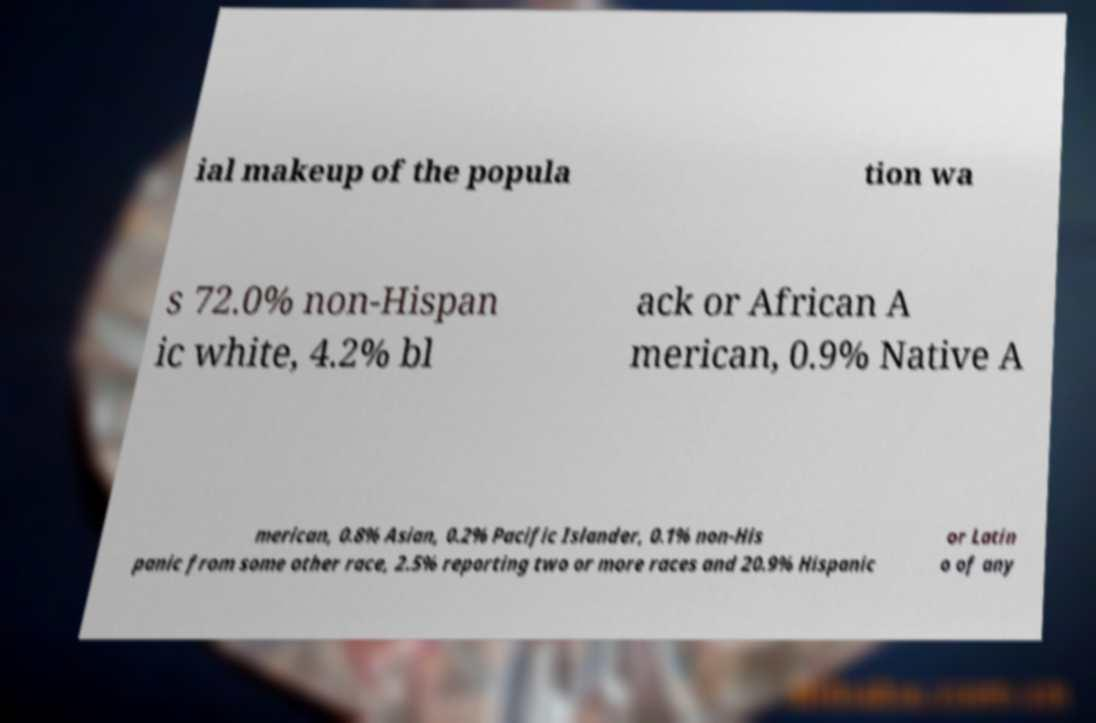What messages or text are displayed in this image? I need them in a readable, typed format. ial makeup of the popula tion wa s 72.0% non-Hispan ic white, 4.2% bl ack or African A merican, 0.9% Native A merican, 0.8% Asian, 0.2% Pacific Islander, 0.1% non-His panic from some other race, 2.5% reporting two or more races and 20.9% Hispanic or Latin o of any 